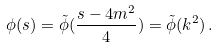<formula> <loc_0><loc_0><loc_500><loc_500>\phi ( s ) = \tilde { \phi } ( \frac { s - 4 m ^ { 2 } } { 4 } ) = \tilde { \phi } ( k ^ { 2 } ) \, .</formula> 